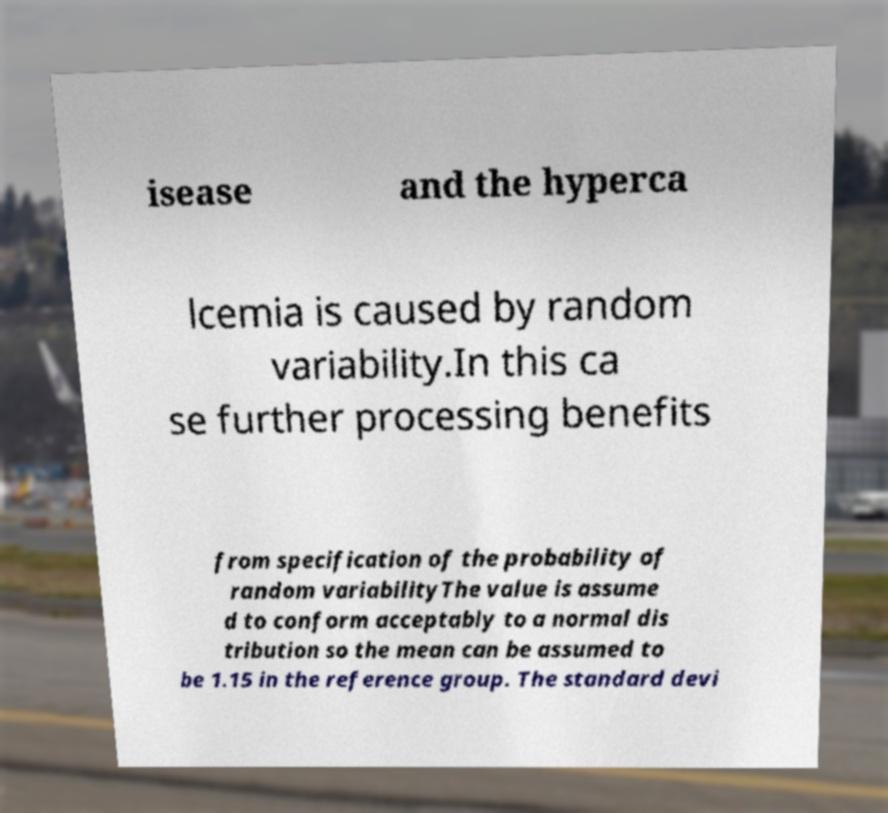There's text embedded in this image that I need extracted. Can you transcribe it verbatim? isease and the hyperca lcemia is caused by random variability.In this ca se further processing benefits from specification of the probability of random variabilityThe value is assume d to conform acceptably to a normal dis tribution so the mean can be assumed to be 1.15 in the reference group. The standard devi 